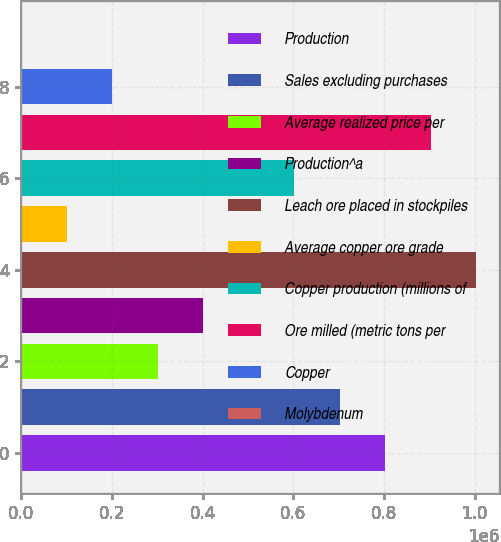Convert chart. <chart><loc_0><loc_0><loc_500><loc_500><bar_chart><fcel>Production<fcel>Sales excluding purchases<fcel>Average realized price per<fcel>Production^a<fcel>Leach ore placed in stockpiles<fcel>Average copper ore grade<fcel>Copper production (millions of<fcel>Ore milled (metric tons per<fcel>Copper<fcel>Molybdenum<nl><fcel>802800<fcel>702450<fcel>301050<fcel>401400<fcel>1.0035e+06<fcel>100350<fcel>602100<fcel>903150<fcel>200700<fcel>0.03<nl></chart> 